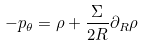Convert formula to latex. <formula><loc_0><loc_0><loc_500><loc_500>- p _ { \theta } = \rho + \frac { \Sigma } { 2 R } \partial _ { R } \rho</formula> 